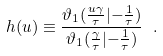<formula> <loc_0><loc_0><loc_500><loc_500>h ( u ) \equiv { \frac { \vartheta _ { 1 } ( { \frac { u \gamma } { \tau } } | { - { \frac { 1 } { \tau } } } ) } { \vartheta _ { 1 } ( { \frac { \gamma } { \tau } } | { - { \frac { 1 } { \tau } } } ) } } \ .</formula> 